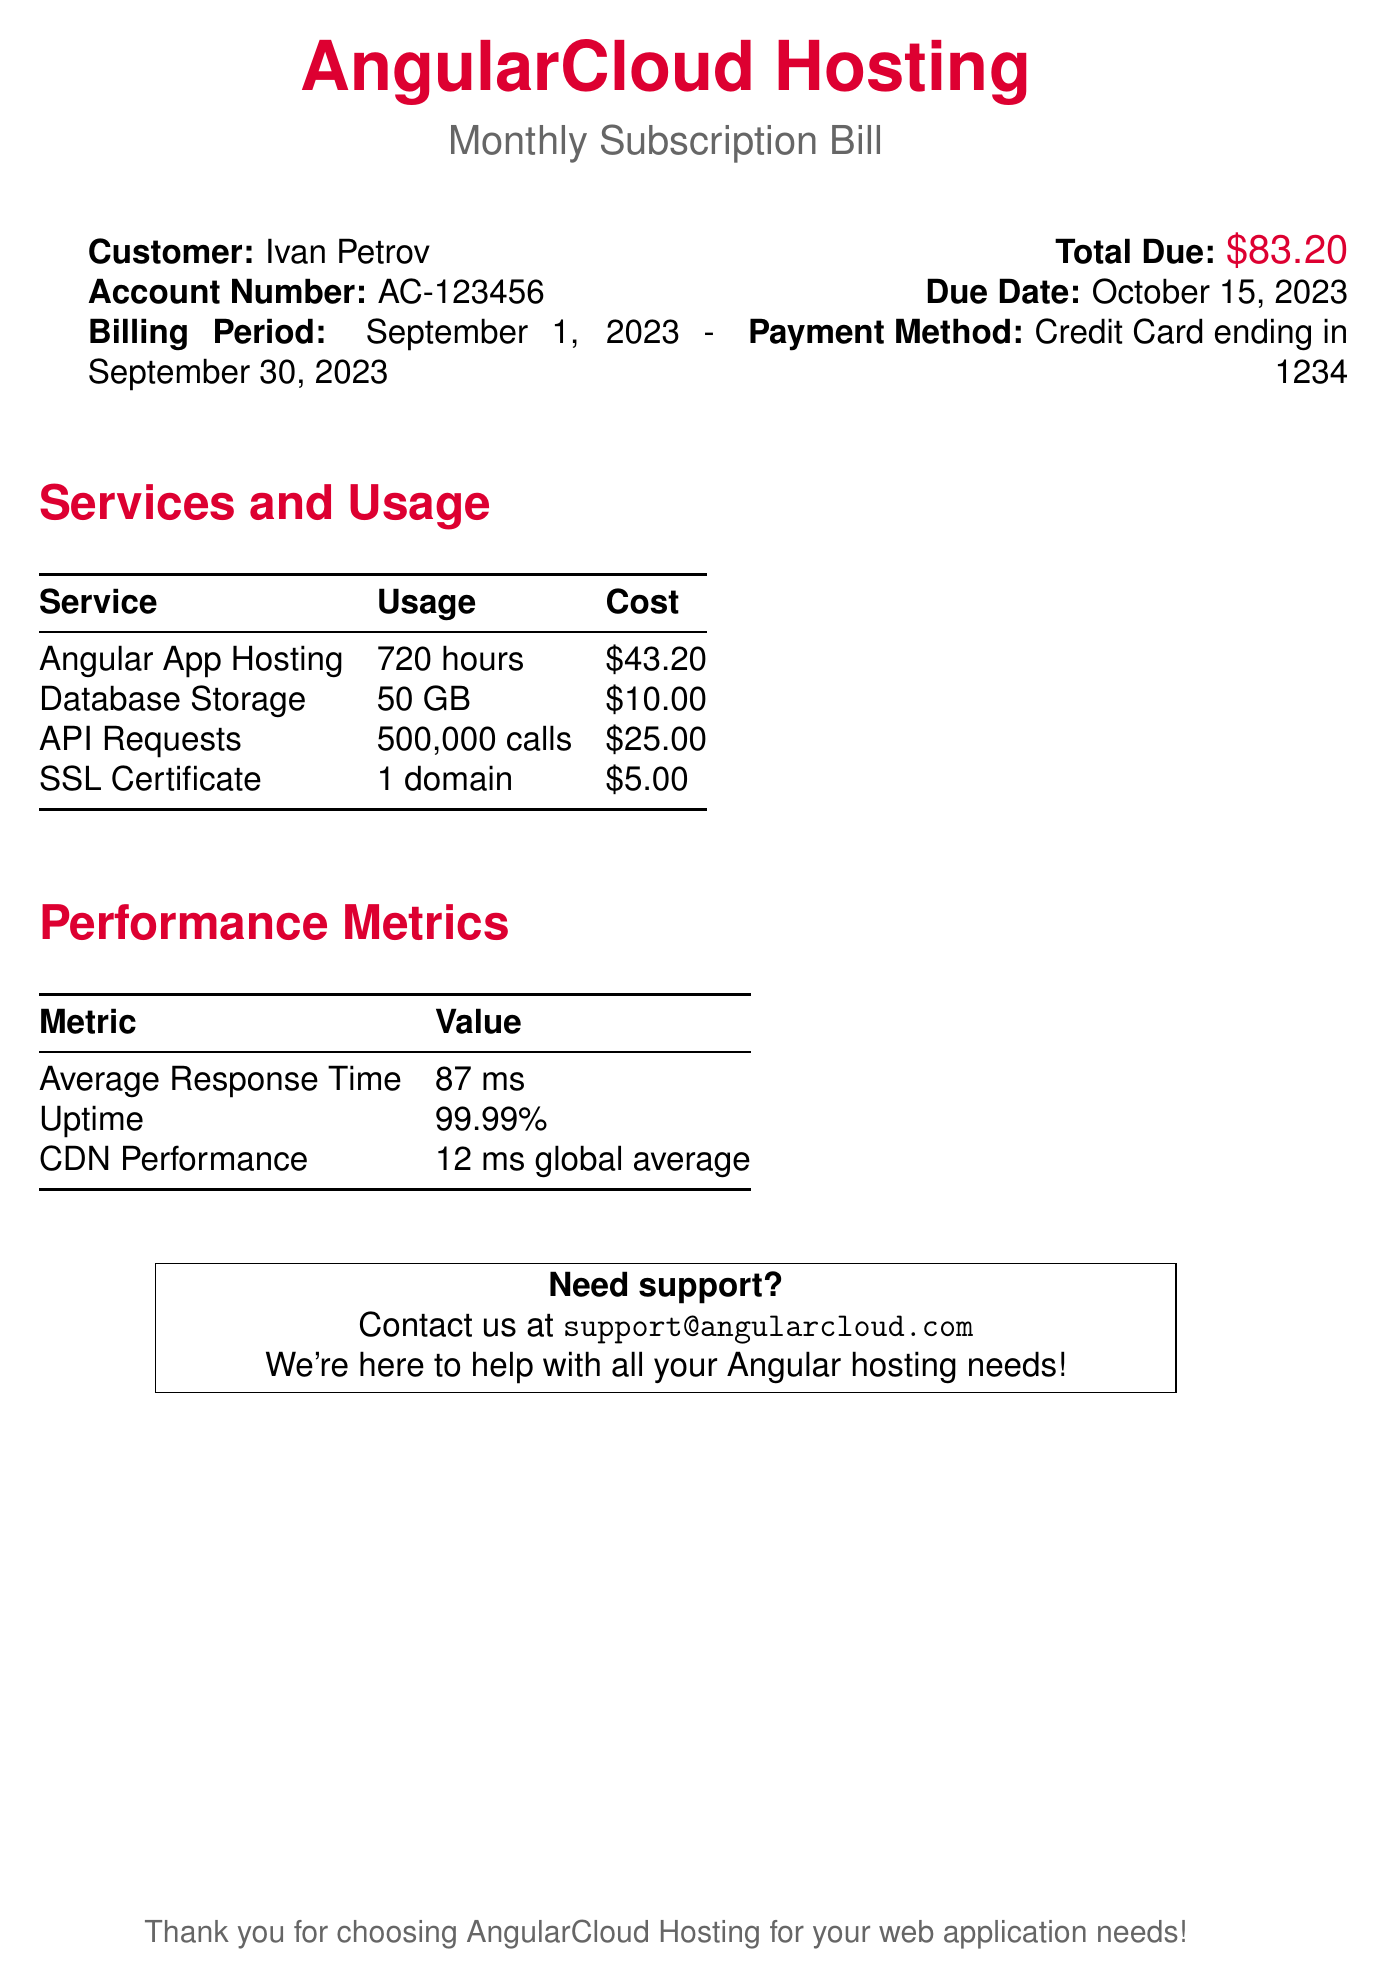What is the billing period? The billing period is stated in the document as the time frame for which the services were billed, from September 1, 2023 to September 30, 2023.
Answer: September 1, 2023 - September 30, 2023 What is the total due amount? The total due amount is clearly indicated in the document as the final charge for the services used during the billing period.
Answer: $83.20 Who is the customer? The document specifies the customer’s name at the top, making it easy to identify whose account this bill relates to.
Answer: Ivan Petrov What is the average response time? The average response time metric mentioned in the performance metrics section provides insight into the speed of the hosted services.
Answer: 87 ms How many API requests were made? The total number of API requests is listed in the services and usage breakdown of the bill.
Answer: 500,000 calls What is the uptime percentage? The uptime value represented in the performance metrics section indicates the reliability of the hosting service.
Answer: 99.99% What service had the highest cost? By comparing the costs of each service listed, we find which one contributed the most to the total bill.
Answer: Angular App Hosting What payment method was used? The document specifies the method of payment made for the services and the last four digits of the card used.
Answer: Credit Card ending in 1234 